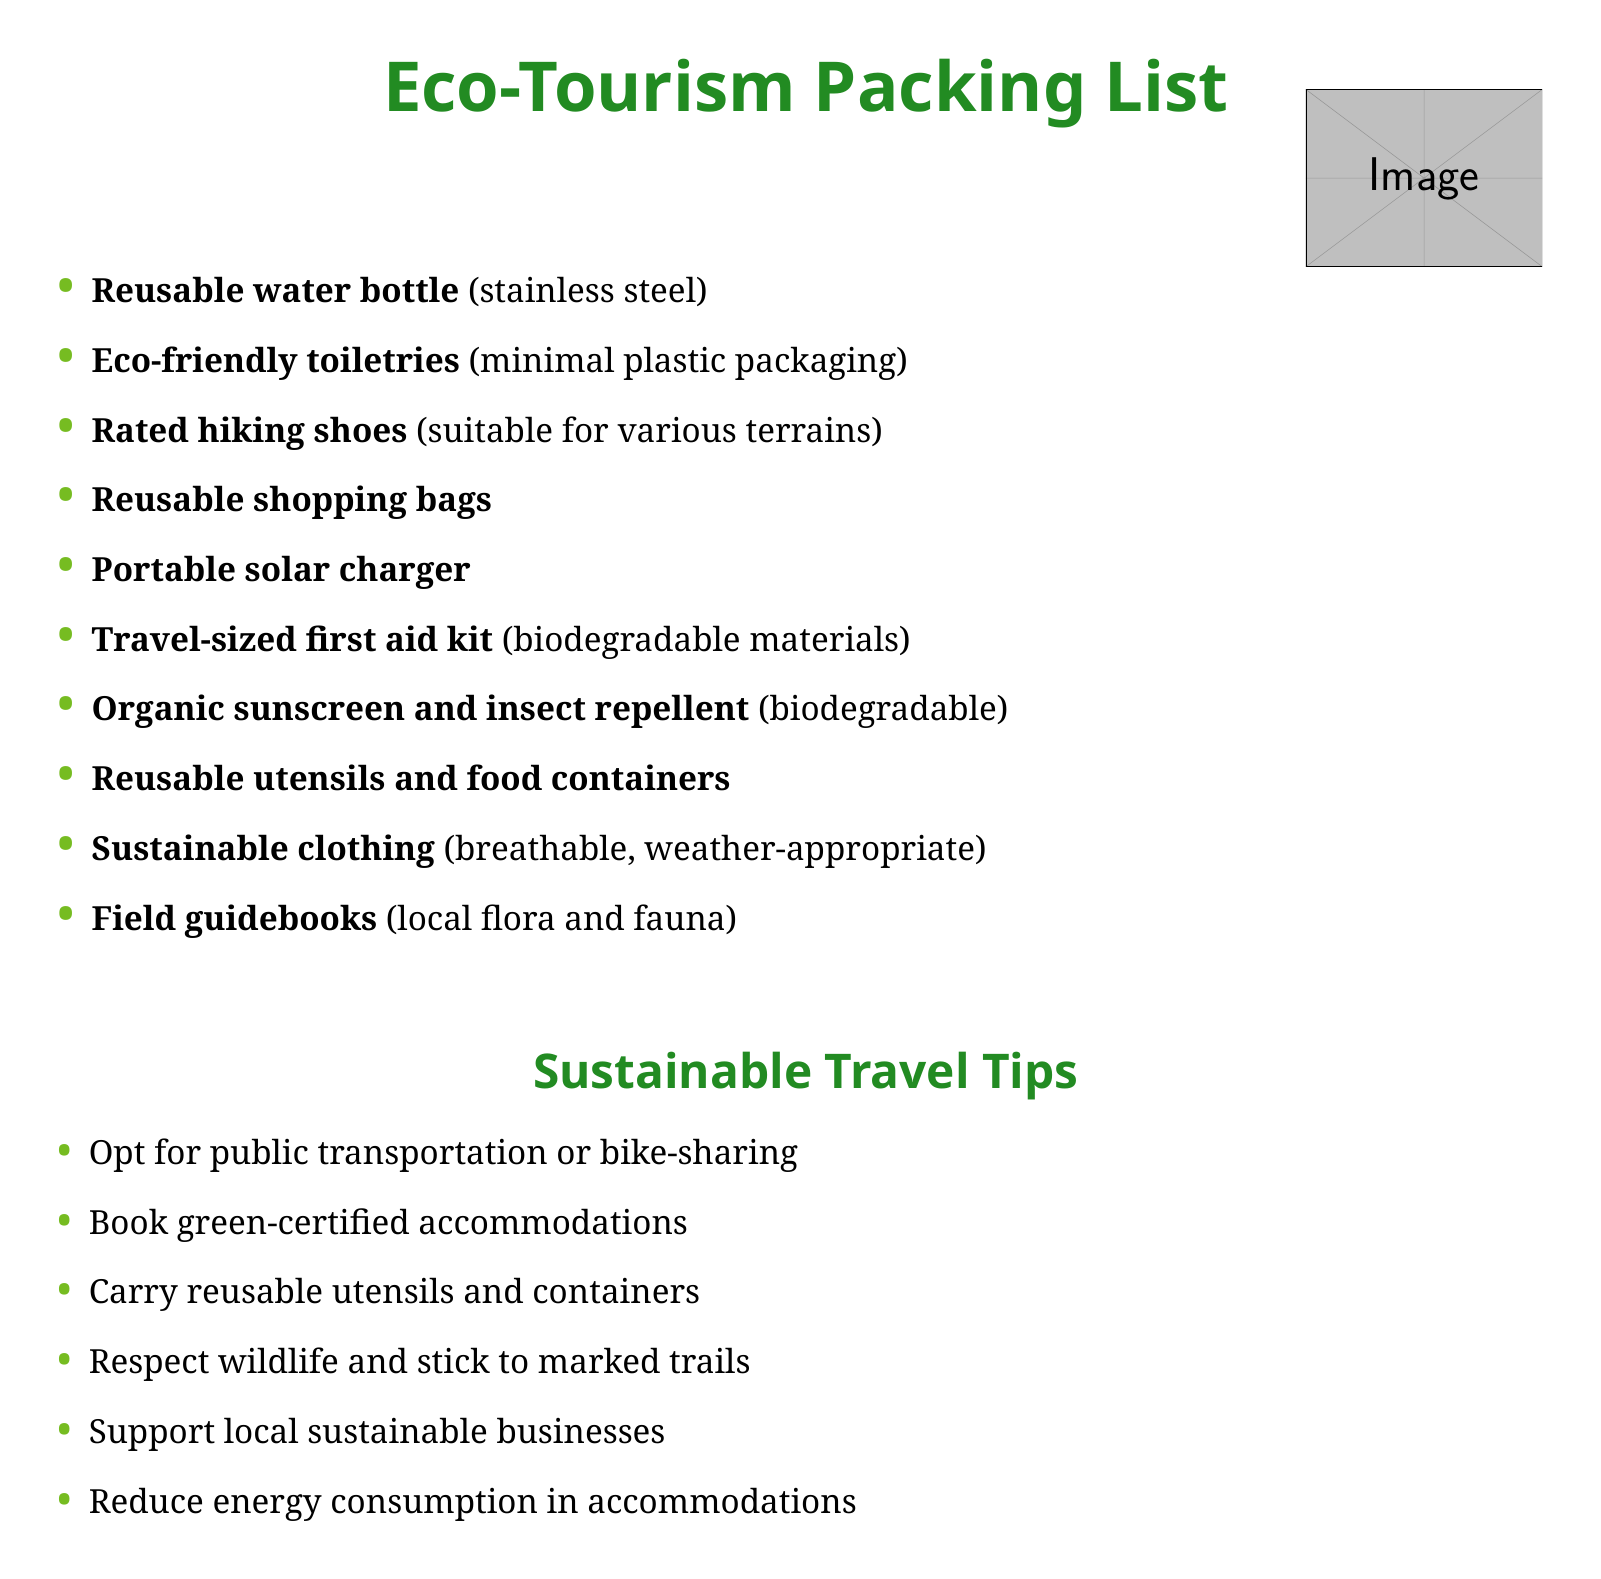what is the first item on the packing list? The first item listed in the packing list is a reusable water bottle.
Answer: reusable water bottle how many items are listed under eco-tourism packing list? There are a total of ten items listed under the eco-tourism packing list.
Answer: 10 what type of charger is recommended in the packing checklist? The packing checklist recommends a portable solar charger.
Answer: portable solar charger which material is recommended for the first aid kit? The document specifies that the first aid kit should be made of biodegradable materials.
Answer: biodegradable materials name one sustainable travel tip provided in the document. One of the sustainable travel tips is to opt for public transportation or bike-sharing.
Answer: opt for public transportation or bike-sharing what category do the toiletries belong to in the packing list? The toiletries listed in the packing list are eco-friendly, emphasizing minimal plastic packaging.
Answer: eco-friendly toiletries how many sustainable travel tips are provided in the document? The document provides six sustainable travel tips.
Answer: 6 what type of clothing is suggested for eco-tourism? The packing list suggests wearing sustainable clothing that is breathable and weather-appropriate.
Answer: sustainable clothing 